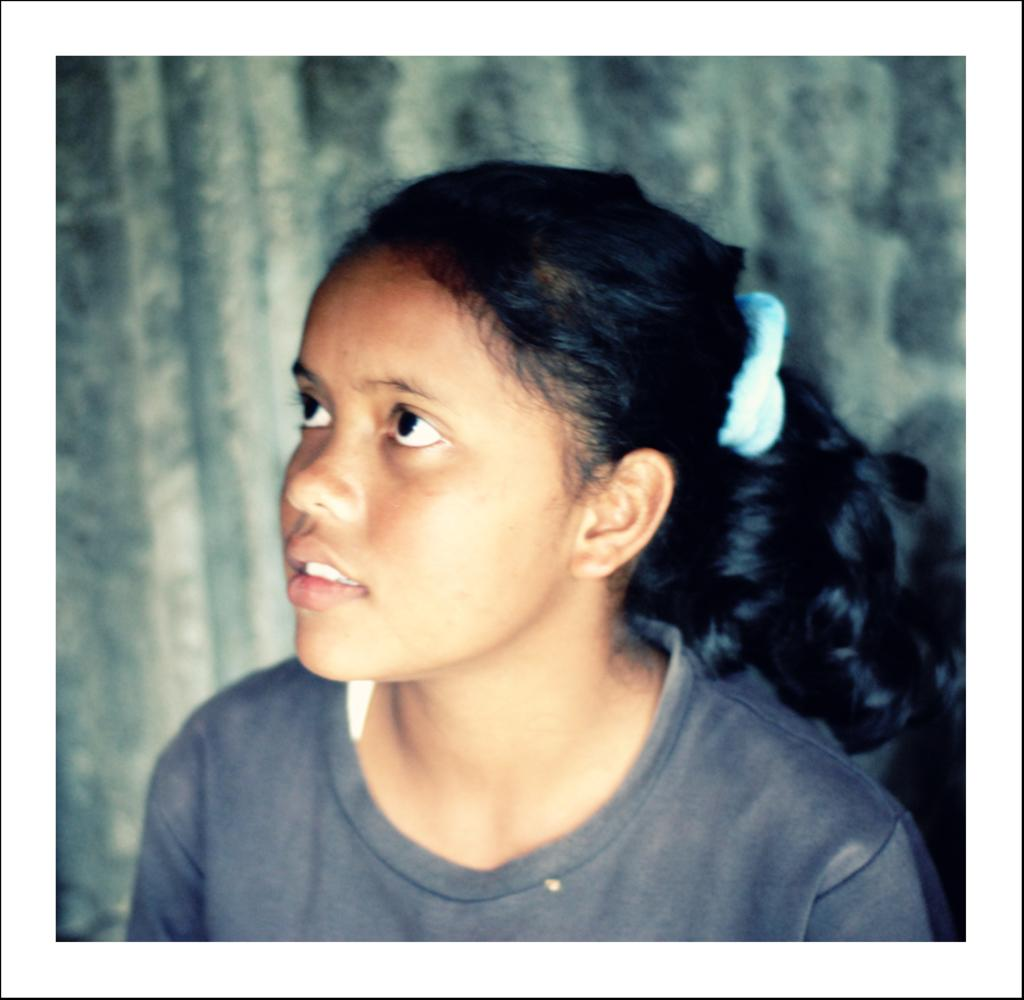Who is the main subject in the image? There is a girl in the image. What is the girl wearing? The girl is wearing a gray shirt. How is the girl's hair styled? The girl has a ponytail. In which direction is the girl looking? The girl is looking to her left side upwards. What can be observed about the background of the image? The background of the girl is blurred. What type of bell can be seen hanging from the girl's ponytail in the image? There is no bell present in the girl's ponytail or anywhere else in the image. 